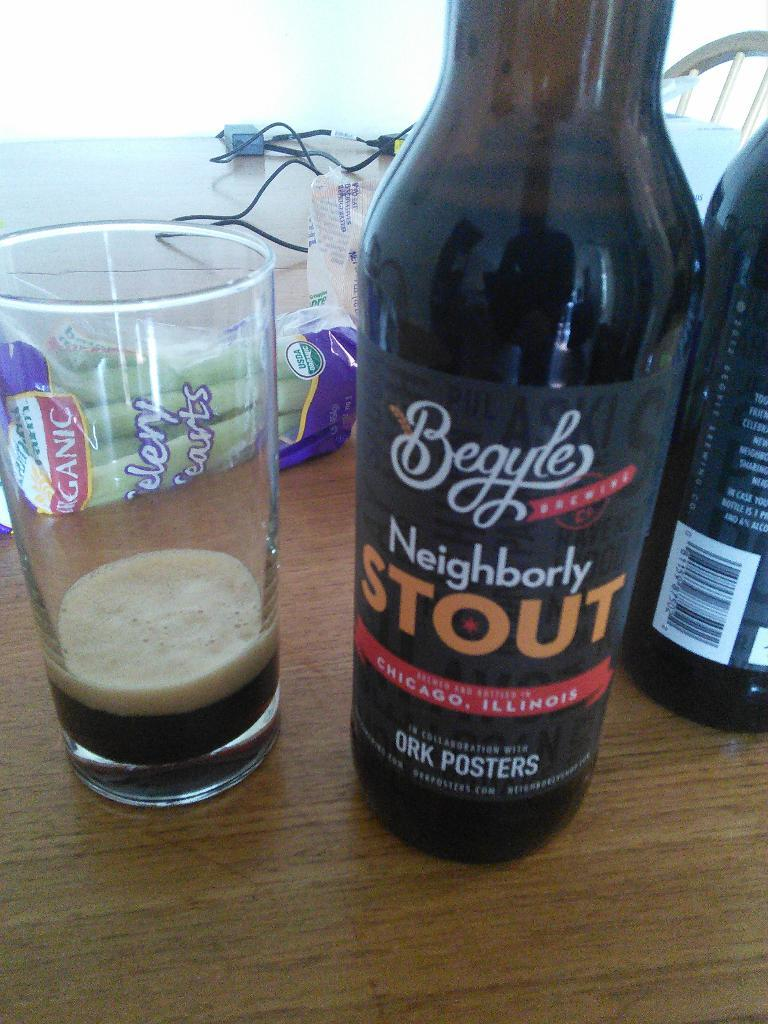<image>
Present a compact description of the photo's key features. A glass of beer that's almost been completely drained sits next to a bottle of Neighborly Stout. 